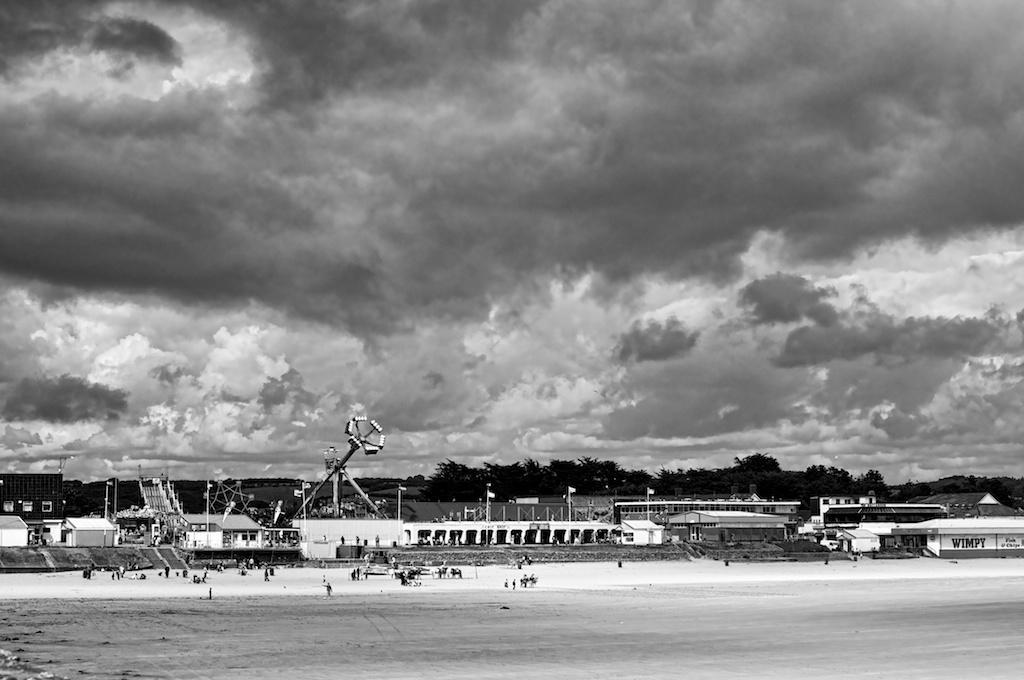Could you give a brief overview of what you see in this image? This is a black and white picture, there are many people standing and walking on the land and behind there are many buildings all over the place and it seems to be a carnival in the middle, over the background there are trees and above its sky with clouds. 